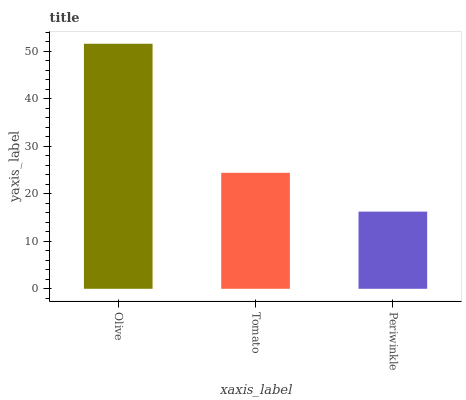Is Tomato the minimum?
Answer yes or no. No. Is Tomato the maximum?
Answer yes or no. No. Is Olive greater than Tomato?
Answer yes or no. Yes. Is Tomato less than Olive?
Answer yes or no. Yes. Is Tomato greater than Olive?
Answer yes or no. No. Is Olive less than Tomato?
Answer yes or no. No. Is Tomato the high median?
Answer yes or no. Yes. Is Tomato the low median?
Answer yes or no. Yes. Is Periwinkle the high median?
Answer yes or no. No. Is Olive the low median?
Answer yes or no. No. 